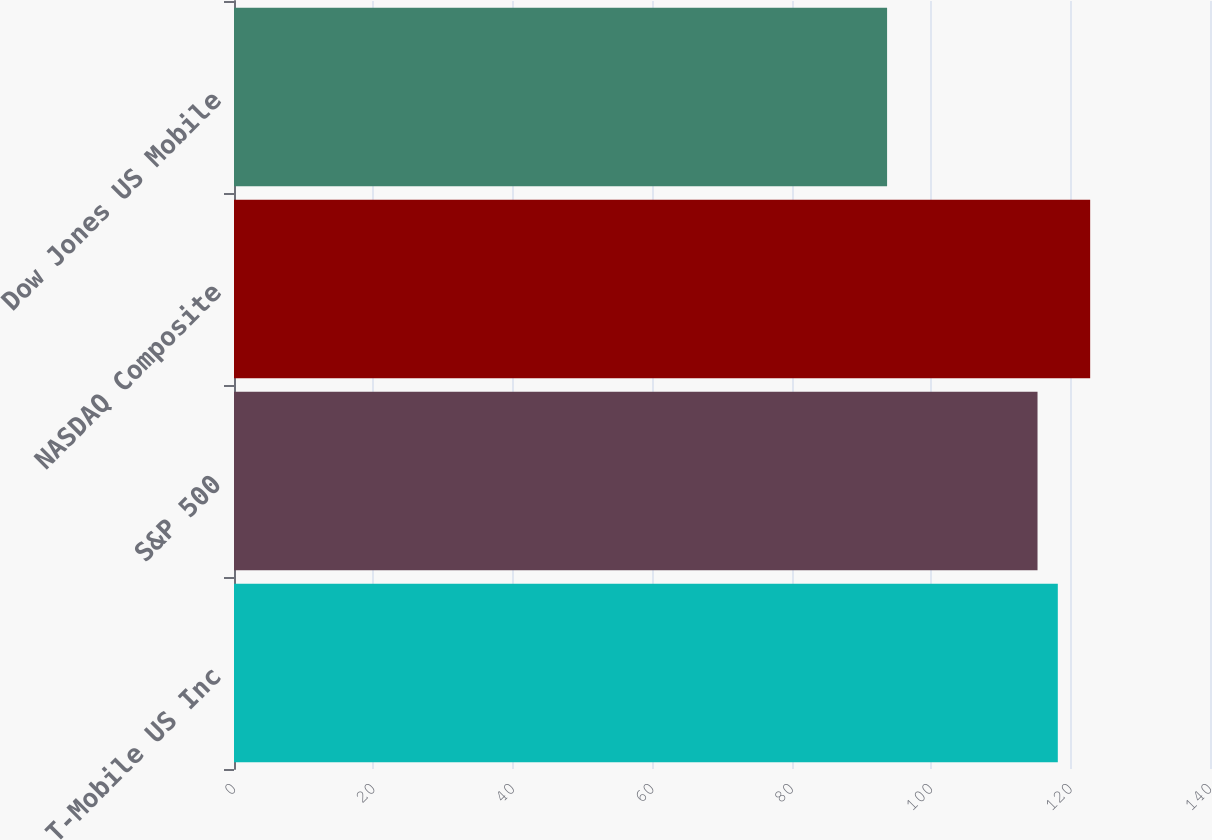<chart> <loc_0><loc_0><loc_500><loc_500><bar_chart><fcel>T-Mobile US Inc<fcel>S&P 500<fcel>NASDAQ Composite<fcel>Dow Jones US Mobile<nl><fcel>118.17<fcel>115.26<fcel>122.81<fcel>93.68<nl></chart> 